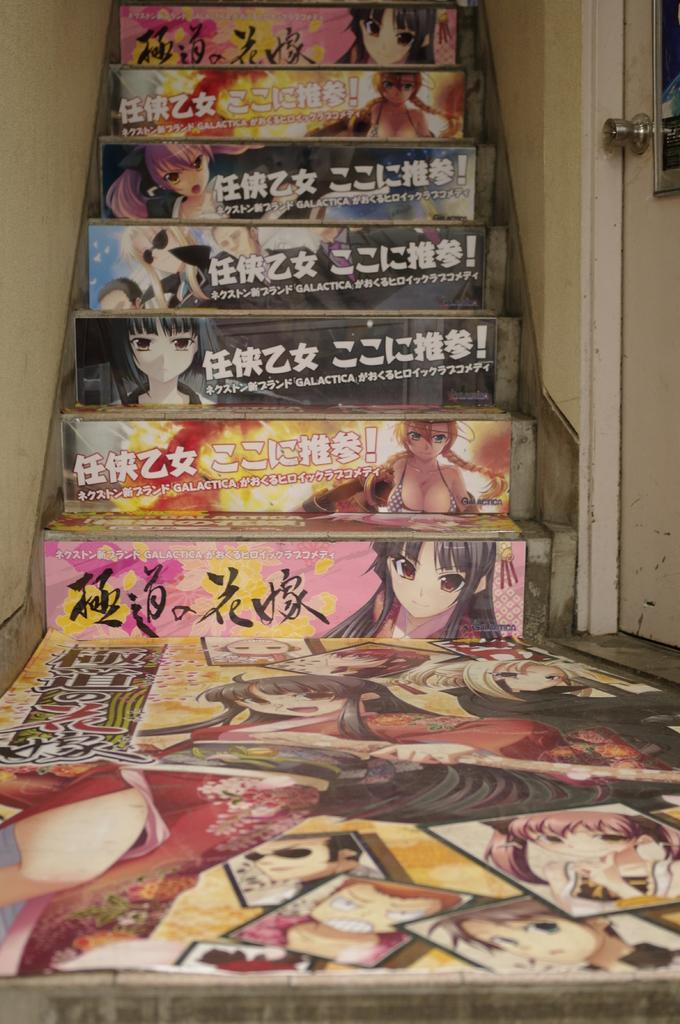Can you describe this image briefly? In this picture, we can see a staircase and on the staircase they are looking like posters and on the right side of the staircase there is a wall and a door. 